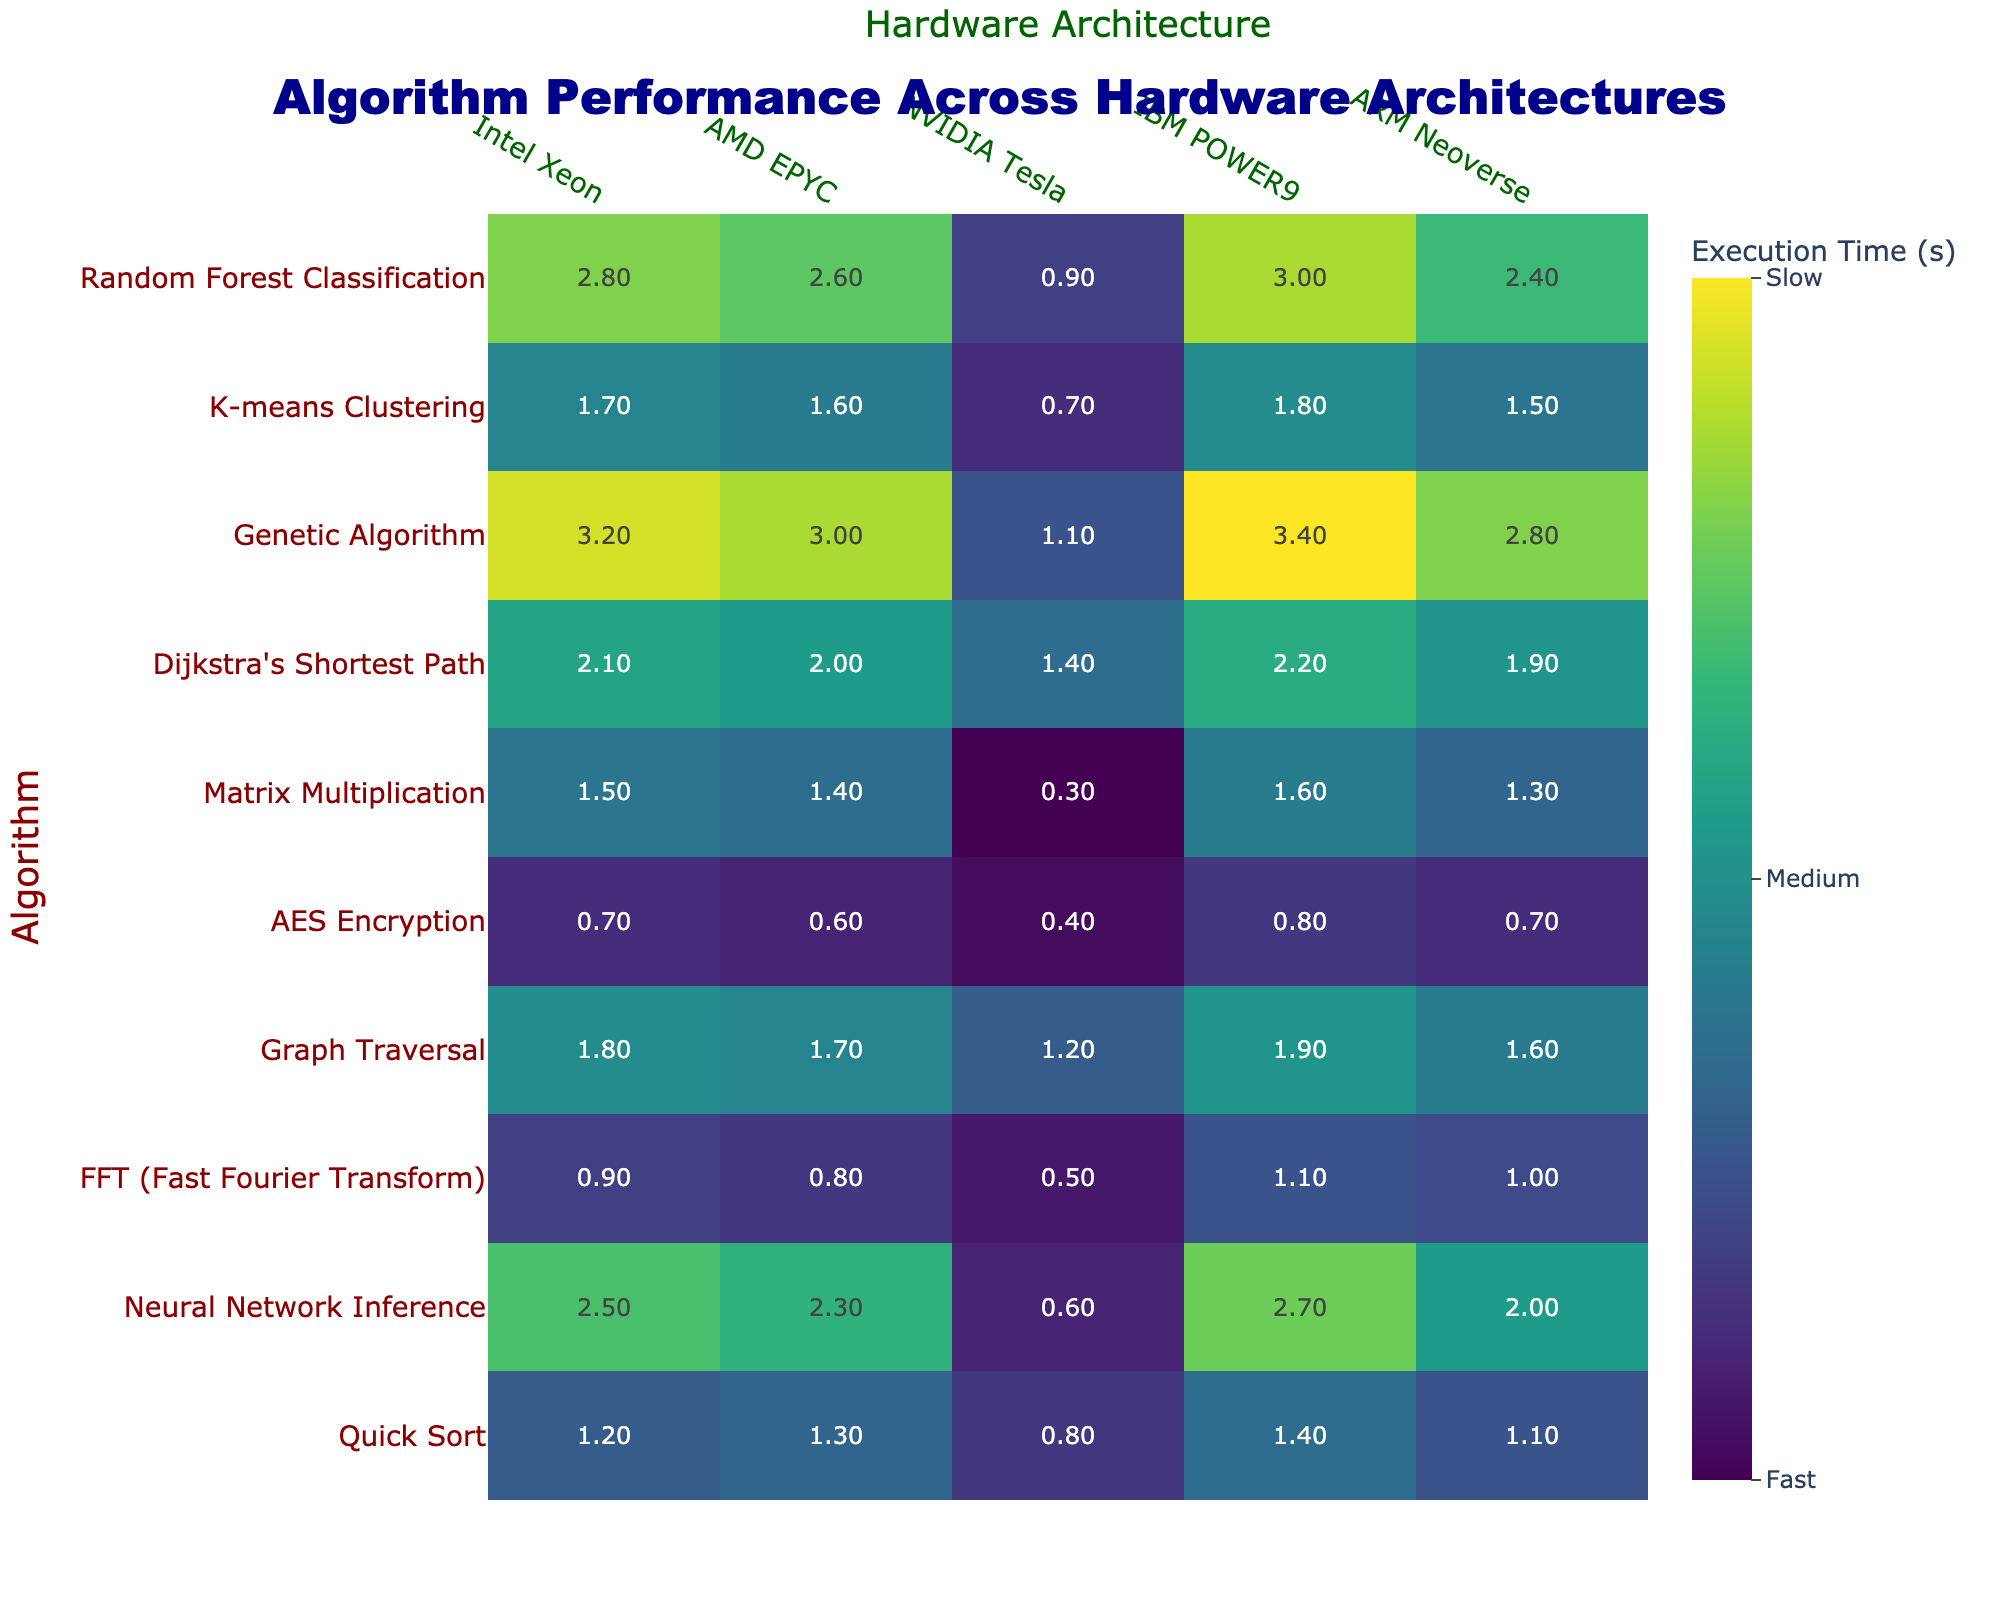What is the execution time for Quick Sort on the Intel Xeon architecture? Quick Sort's execution time on the Intel Xeon architecture is displayed in the table as 1.2 seconds.
Answer: 1.2 seconds Which algorithm has the fastest execution time on the NVIDIA Tesla architecture? The table shows that Matrix Multiplication has the fastest execution time on NVIDIA Tesla at 0.3 seconds.
Answer: Matrix Multiplication What is the average execution time for Neural Network Inference and Random Forest Classification on the AMD EPYC architecture? Neural Network Inference has an execution time of 2.3 seconds and Random Forest Classification has 2.6 seconds. The average is calculated as (2.3 + 2.6) / 2 = 2.45 seconds.
Answer: 2.45 seconds Is the execution time for AES Encryption on ARM Neoverse greater than 0.6 seconds? The table indicates that AES Encryption has an execution time of 0.7 seconds on ARM Neoverse, which is greater than 0.6 seconds.
Answer: Yes Which hardware architecture performs best for Dijkstra's Shortest Path algorithm? The fastest execution time for Dijkstra's Shortest Path is 2.1 seconds, which corresponds to Intel Xeon based on the table.
Answer: Intel Xeon What is the difference in execution time between Graph Traversal on IBM POWER9 and ARM Neoverse? Graph Traversal executes in 1.9 seconds on IBM POWER9 and 1.6 seconds on ARM Neoverse. The difference is 1.9 - 1.6 = 0.3 seconds.
Answer: 0.3 seconds If a hardware project requires the least execution time for FFT, which architecture should be chosen? The FFT has the least execution time of 0.5 seconds on NVIDIA Tesla, making it the best choice.
Answer: NVIDIA Tesla How does the performance of the Genetic Algorithm on IBM POWER9 compare to that on ARM Neoverse? The Genetic Algorithm executes in 3.4 seconds on IBM POWER9 and 2.8 seconds on ARM Neoverse. IBM POWER9’s time is slower by 0.6 seconds.
Answer: 0.6 seconds slower Which algorithm performs better on AMD EPYC compared to Intel Xeon? The table shows that the performance for Genetic Algorithm (3.0 vs 3.2) and K-means Clustering (1.6 vs 1.7) is worse on AMD EPYC compared to Intel Xeon.
Answer: No algorithms perform better What is the total execution time for Quick Sort, FFT and K-means Clustering on ARM Neoverse? Quick Sort takes 1.1 seconds, FFT takes 1.0 seconds, and K-means Clustering takes 1.5 seconds on ARM Neoverse. The total is 1.1 + 1.0 + 1.5 = 3.6 seconds.
Answer: 3.6 seconds How many algorithms have an execution time greater than 2.5 seconds on Intel Xeon? Looking at the table, the algorithms exceeding 2.5 seconds are Neural Network Inference (2.5), Dijkstra's Shortest Path (2.1), Genetic Algorithm (3.2), and Random Forest Classification (2.8); hence, 3 algorithms meet the criteria.
Answer: 3 algorithms 